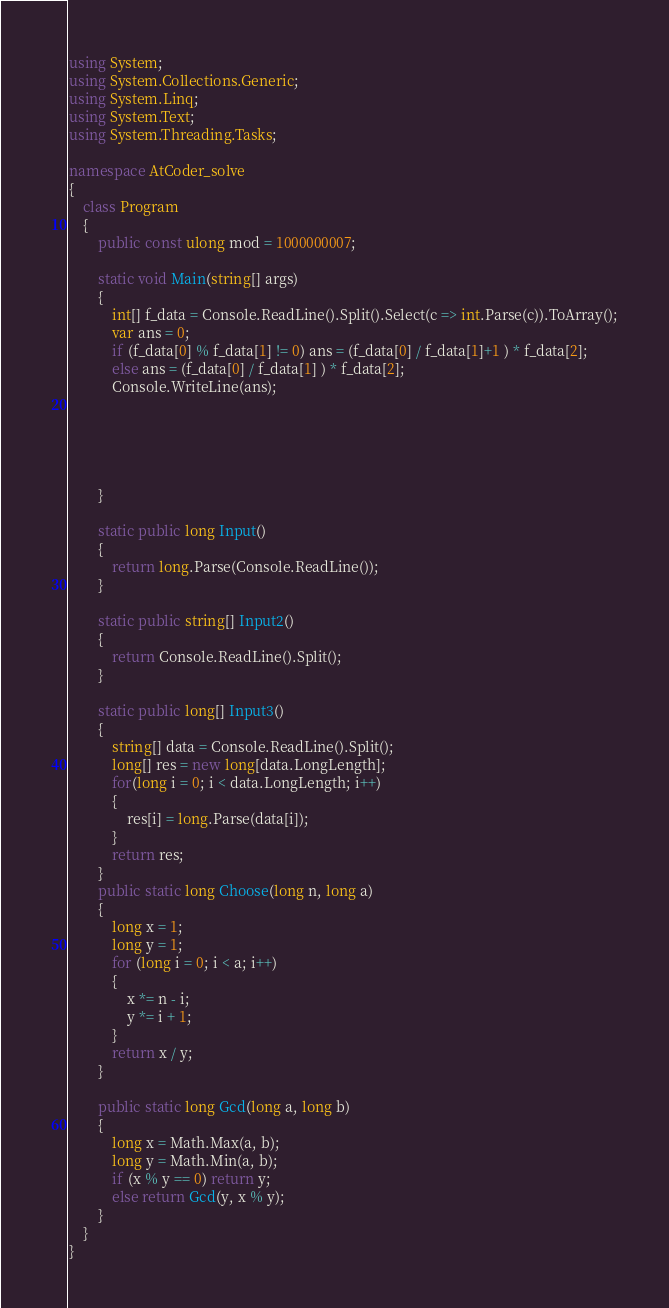<code> <loc_0><loc_0><loc_500><loc_500><_C#_>using System;
using System.Collections.Generic;
using System.Linq;
using System.Text;
using System.Threading.Tasks;

namespace AtCoder_solve
{
    class Program
    {
        public const ulong mod = 1000000007;

        static void Main(string[] args)
        {
            int[] f_data = Console.ReadLine().Split().Select(c => int.Parse(c)).ToArray();
            var ans = 0;
            if (f_data[0] % f_data[1] != 0) ans = (f_data[0] / f_data[1]+1 ) * f_data[2];
            else ans = (f_data[0] / f_data[1] ) * f_data[2];
            Console.WriteLine(ans);





        }

        static public long Input()
        {
            return long.Parse(Console.ReadLine());
        }

        static public string[] Input2()
        {
            return Console.ReadLine().Split();
        }
        
        static public long[] Input3()
        {
            string[] data = Console.ReadLine().Split();
            long[] res = new long[data.LongLength];
            for(long i = 0; i < data.LongLength; i++)
            {
                res[i] = long.Parse(data[i]);
            }
            return res;
        }
        public static long Choose(long n, long a)
        {
            long x = 1;
            long y = 1;
            for (long i = 0; i < a; i++)
            {
                x *= n - i;
                y *= i + 1;
            }
            return x / y;
        }

        public static long Gcd(long a, long b)
        {
            long x = Math.Max(a, b);
            long y = Math.Min(a, b);
            if (x % y == 0) return y;
            else return Gcd(y, x % y);
        }
    }
}
</code> 